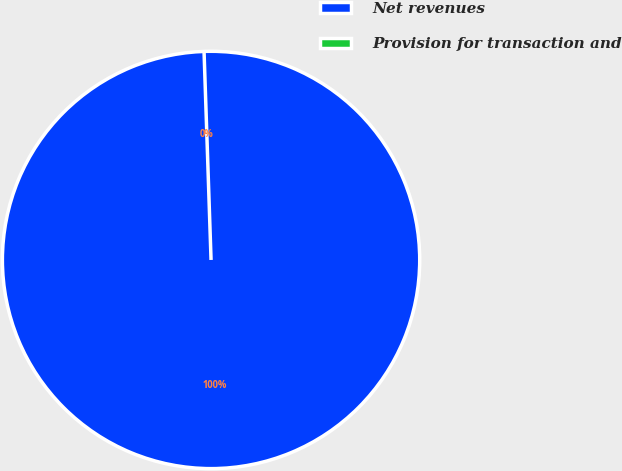Convert chart to OTSL. <chart><loc_0><loc_0><loc_500><loc_500><pie_chart><fcel>Net revenues<fcel>Provision for transaction and<nl><fcel>100.0%<fcel>0.0%<nl></chart> 